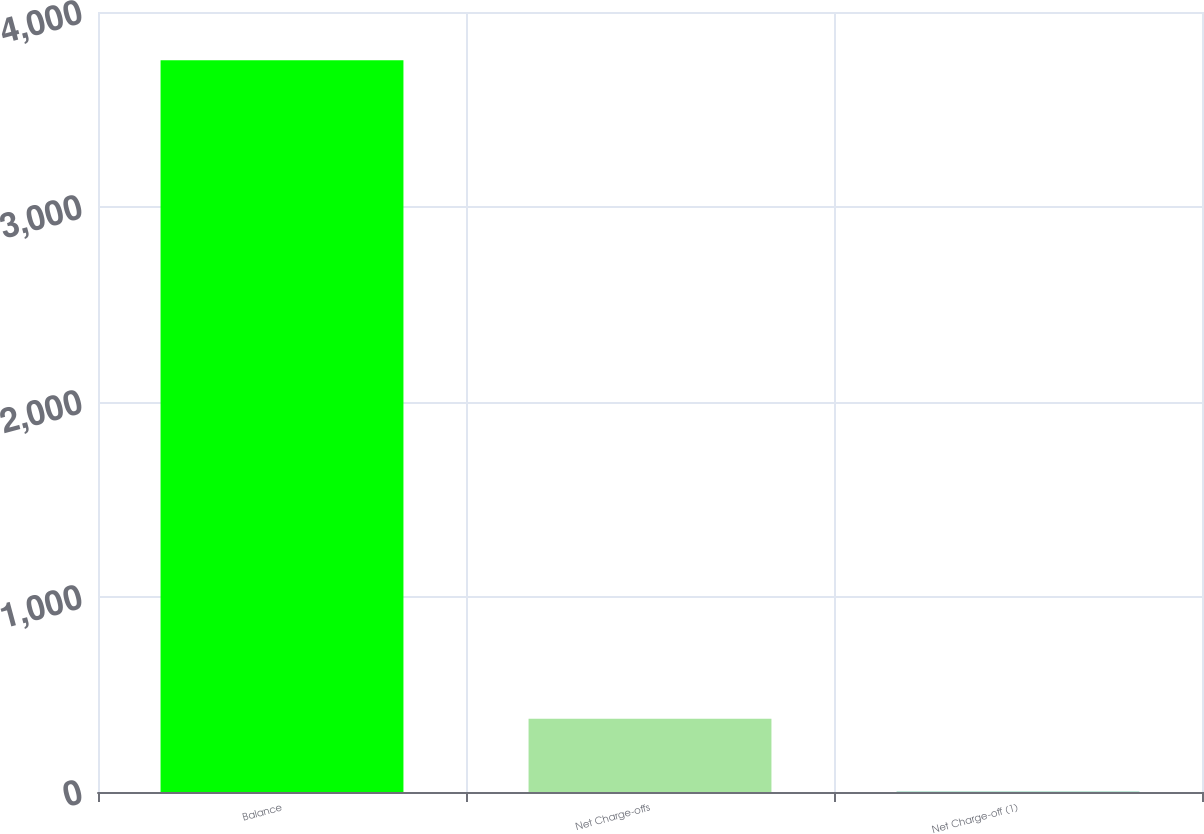Convert chart. <chart><loc_0><loc_0><loc_500><loc_500><bar_chart><fcel>Balance<fcel>Net Charge-offs<fcel>Net Charge-off (1)<nl><fcel>3752<fcel>375.89<fcel>0.77<nl></chart> 